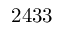Convert formula to latex. <formula><loc_0><loc_0><loc_500><loc_500>2 4 3 3</formula> 